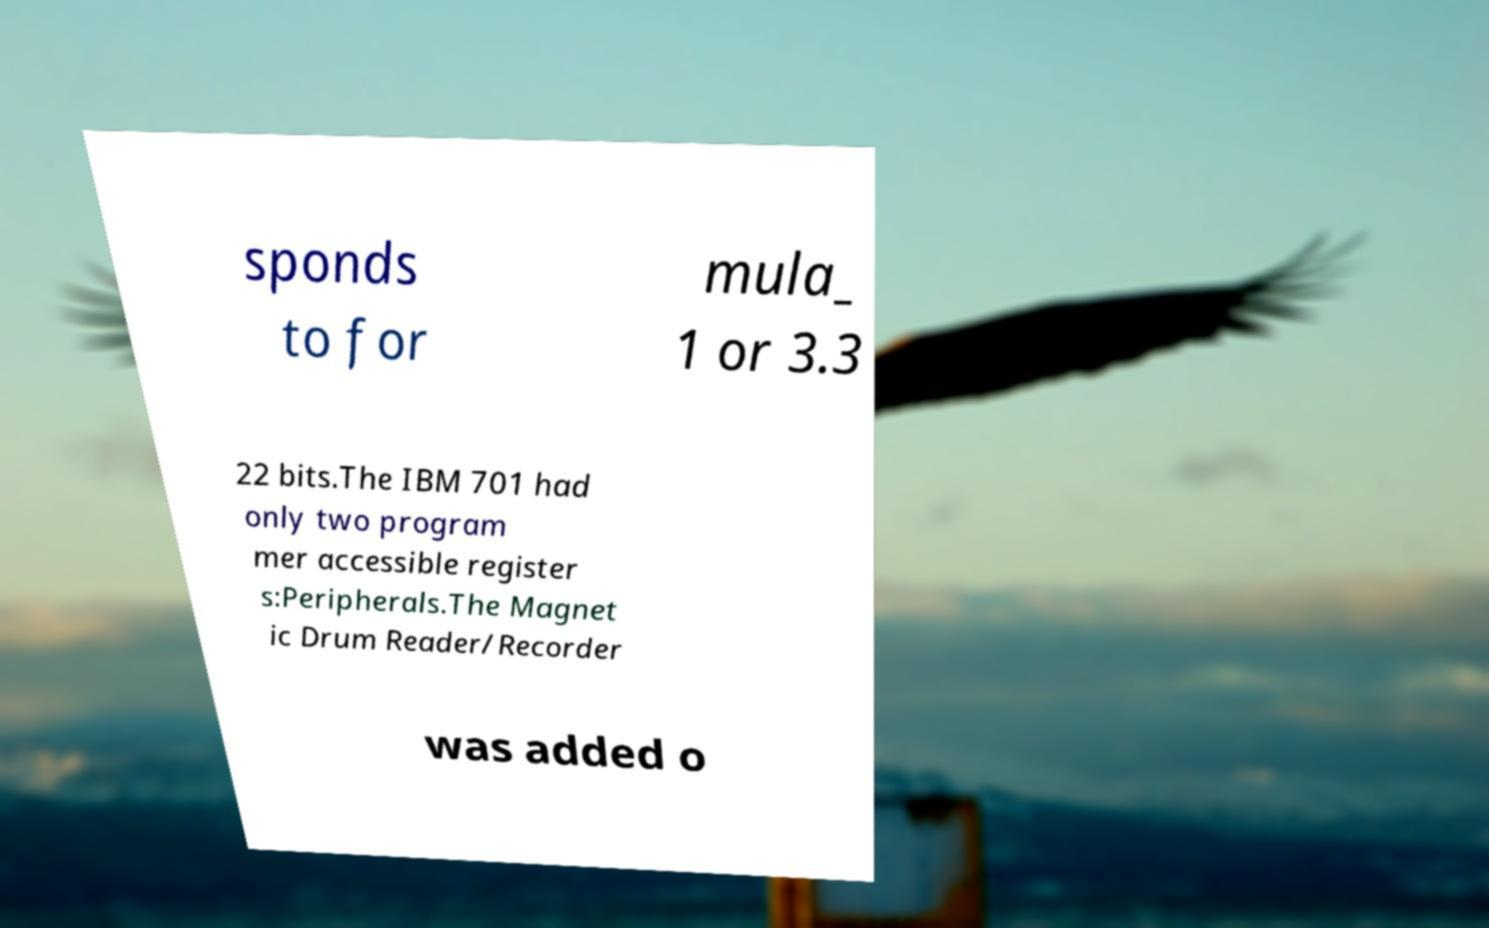What messages or text are displayed in this image? I need them in a readable, typed format. sponds to for mula_ 1 or 3.3 22 bits.The IBM 701 had only two program mer accessible register s:Peripherals.The Magnet ic Drum Reader/Recorder was added o 